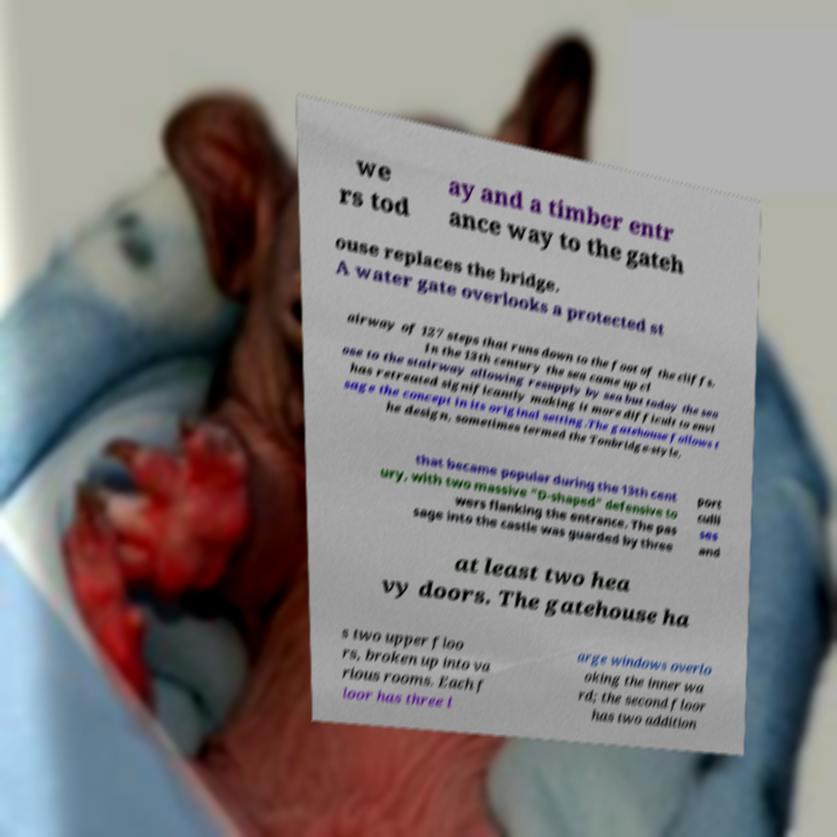Please read and relay the text visible in this image. What does it say? we rs tod ay and a timber entr ance way to the gateh ouse replaces the bridge. A water gate overlooks a protected st airway of 127 steps that runs down to the foot of the cliffs. In the 13th century the sea came up cl ose to the stairway allowing resupply by sea but today the sea has retreated significantly making it more difficult to envi sage the concept in its original setting.The gatehouse follows t he design, sometimes termed the Tonbridge-style, that became popular during the 13th cent ury, with two massive "D-shaped" defensive to wers flanking the entrance. The pas sage into the castle was guarded by three port culli ses and at least two hea vy doors. The gatehouse ha s two upper floo rs, broken up into va rious rooms. Each f loor has three l arge windows overlo oking the inner wa rd; the second floor has two addition 